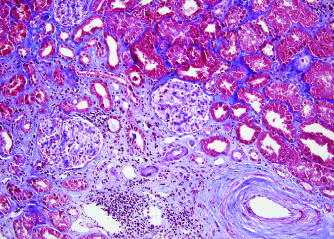what does the blue area show in this trichrome stain, contrasted with the normal kidney (top right)?
Answer the question using a single word or phrase. Fibrosis 